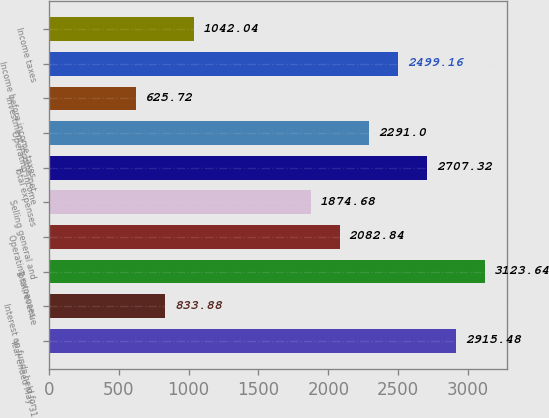Convert chart to OTSL. <chart><loc_0><loc_0><loc_500><loc_500><bar_chart><fcel>Year ended May 31<fcel>Interest on funds held for<fcel>Total revenue<fcel>Operating expenses<fcel>Selling general and<fcel>Total expenses<fcel>Operating income<fcel>Investment income net<fcel>Income before income taxes<fcel>Income taxes<nl><fcel>2915.48<fcel>833.88<fcel>3123.64<fcel>2082.84<fcel>1874.68<fcel>2707.32<fcel>2291<fcel>625.72<fcel>2499.16<fcel>1042.04<nl></chart> 